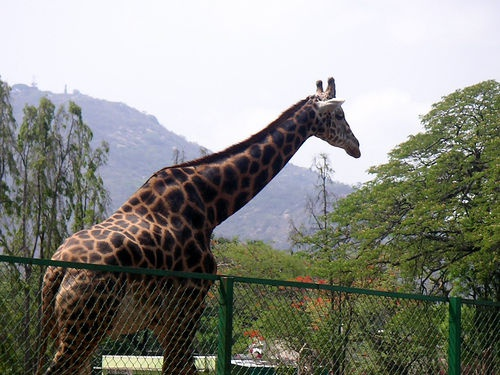Describe the objects in this image and their specific colors. I can see a giraffe in lavender, black, gray, and maroon tones in this image. 